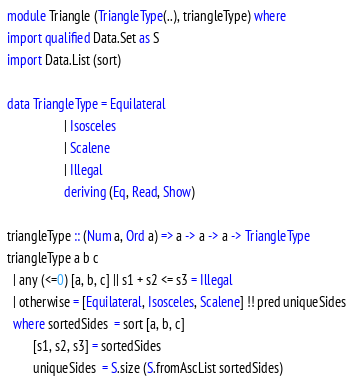Convert code to text. <code><loc_0><loc_0><loc_500><loc_500><_Haskell_>module Triangle (TriangleType(..), triangleType) where
import qualified Data.Set as S
import Data.List (sort)

data TriangleType = Equilateral
                  | Isosceles
                  | Scalene
                  | Illegal
                  deriving (Eq, Read, Show)

triangleType :: (Num a, Ord a) => a -> a -> a -> TriangleType
triangleType a b c
  | any (<=0) [a, b, c] || s1 + s2 <= s3 = Illegal
  | otherwise = [Equilateral, Isosceles, Scalene] !! pred uniqueSides
  where sortedSides  = sort [a, b, c]
        [s1, s2, s3] = sortedSides
        uniqueSides  = S.size (S.fromAscList sortedSides)
</code> 